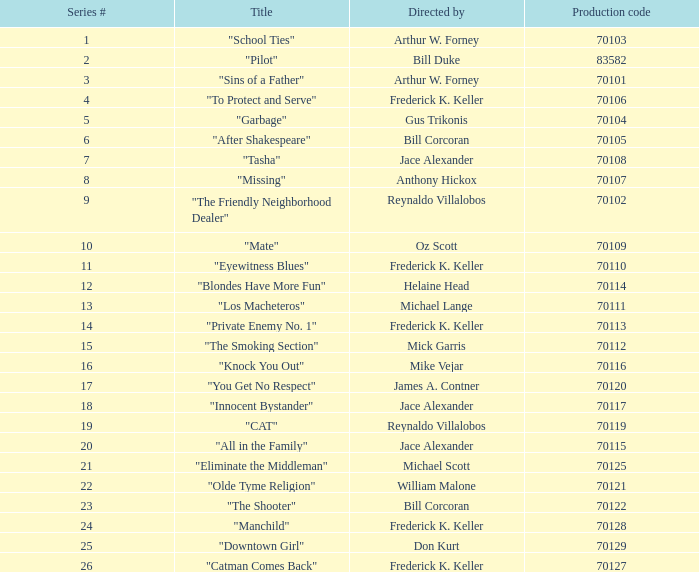For the "Downtown Girl" episode, what was the original air date? May 4, 1995. 